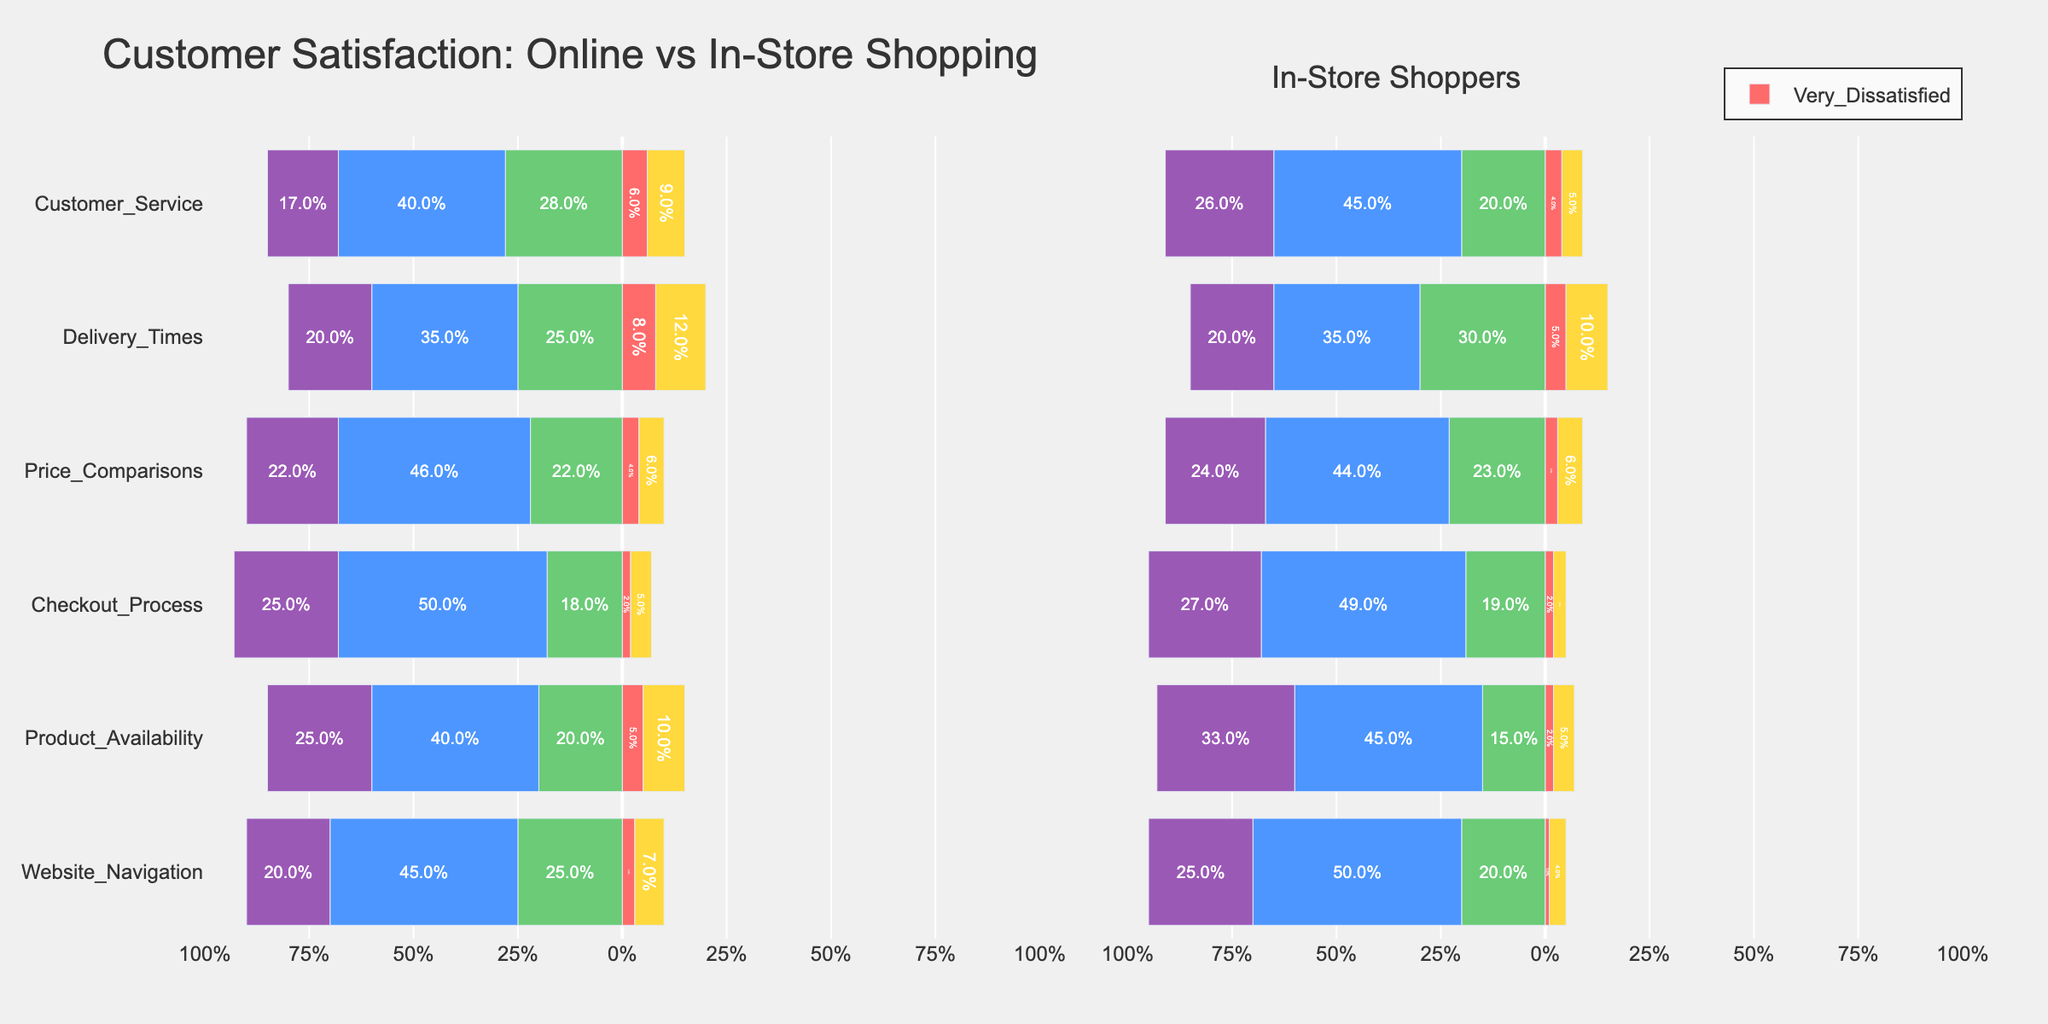What is the most common satisfaction level for Online Shoppers' Checkout Process? Based on the bar lengths for the Checkout Process under Online Shoppers, the "Satisfied" category appears to be the longest. This indicates that the most common satisfaction level is "Satisfied"
Answer: Satisfied Which experience category shows the highest proportion of dissatisfaction (sum of dissatisfied and very dissatisfied) among Online Shoppers? To determine this, we need to sum the proportions of "Dissatisfied" and "Very Dissatisfied" for each experience category among Online Shoppers. By comparison, "Delivery Times" shows the highest combined proportion of dissatisfaction.
Answer: Delivery Times Are Online Shoppers or In-Store Shoppers more likely to be very satisfied with Customer Service? For "Customer Service," the bar representing "Very Satisfied" is longer for In-Store Shoppers compared to Online Shoppers. Therefore, In-Store Shoppers are more likely to be very satisfied with Customer Service.
Answer: In-Store Shoppers What is the difference in percentage of satisfaction ("Satisfied" and "Very Satisfied") for Product Availability between Online and In-Store Shoppers? For Online Shoppers: Satisfied (40%) + Very Satisfied (25%) = 65%. For In-Store Shoppers: Satisfied (45%) + Very Satisfied (33%) = 78%. The difference is 78% - 65% = 13%.
Answer: 13% Which group finds Price Comparisons more satisfying overall? By comparing the lengths of the "Satisfied" and "Very Satisfied" bars for Price Comparisons, we see that In-Store Shoppers generally have longer bars than Online Shoppers, indicating higher overall satisfaction.
Answer: In-Store Shoppers Which experience category has the highest neutral responses among In-Store Shoppers? Looking at the "Neutral" category bars among In-Store Shoppers, the longest bar is for "Parking Facilities." Therefore, "Parking Facilities" has the highest neutral responses.
Answer: Parking Facilities How do Online Shoppers rate Website Navigation compared to In-Store Shoppers' Store Layout in terms of neutral responses? By comparing the "Neutral" responses, we see that Website Navigation for Online Shoppers has a 25% neutral response, while Store Layout for In-Store Shoppers is also 20%. This means the neutral responses are higher for Website Navigation in Online Shoppers.
Answer: Website Navigation defers to be more neutral What proportion of Online Shoppers are either satisfied or very satisfied with the Delivery Times? For Delivery Times in Online Shoppers: Satisfied (35%) + Very Satisfied (20%) = 55%.
Answer: 55% What's the combined percentage of dissatisfaction ("Dissatisfied" and "Very Dissatisfied") for Customer Service among both Online and In-Store Shoppers? For Online Shoppers: Dissatisfied (9%) + Very Dissatisfied (6%) = 15%. For In-Store Shoppers: Dissatisfied (5%) + Very Dissatisfied (4%) = 9%. Combined, it's 15% + 9% = 24%.
Answer: 24% 